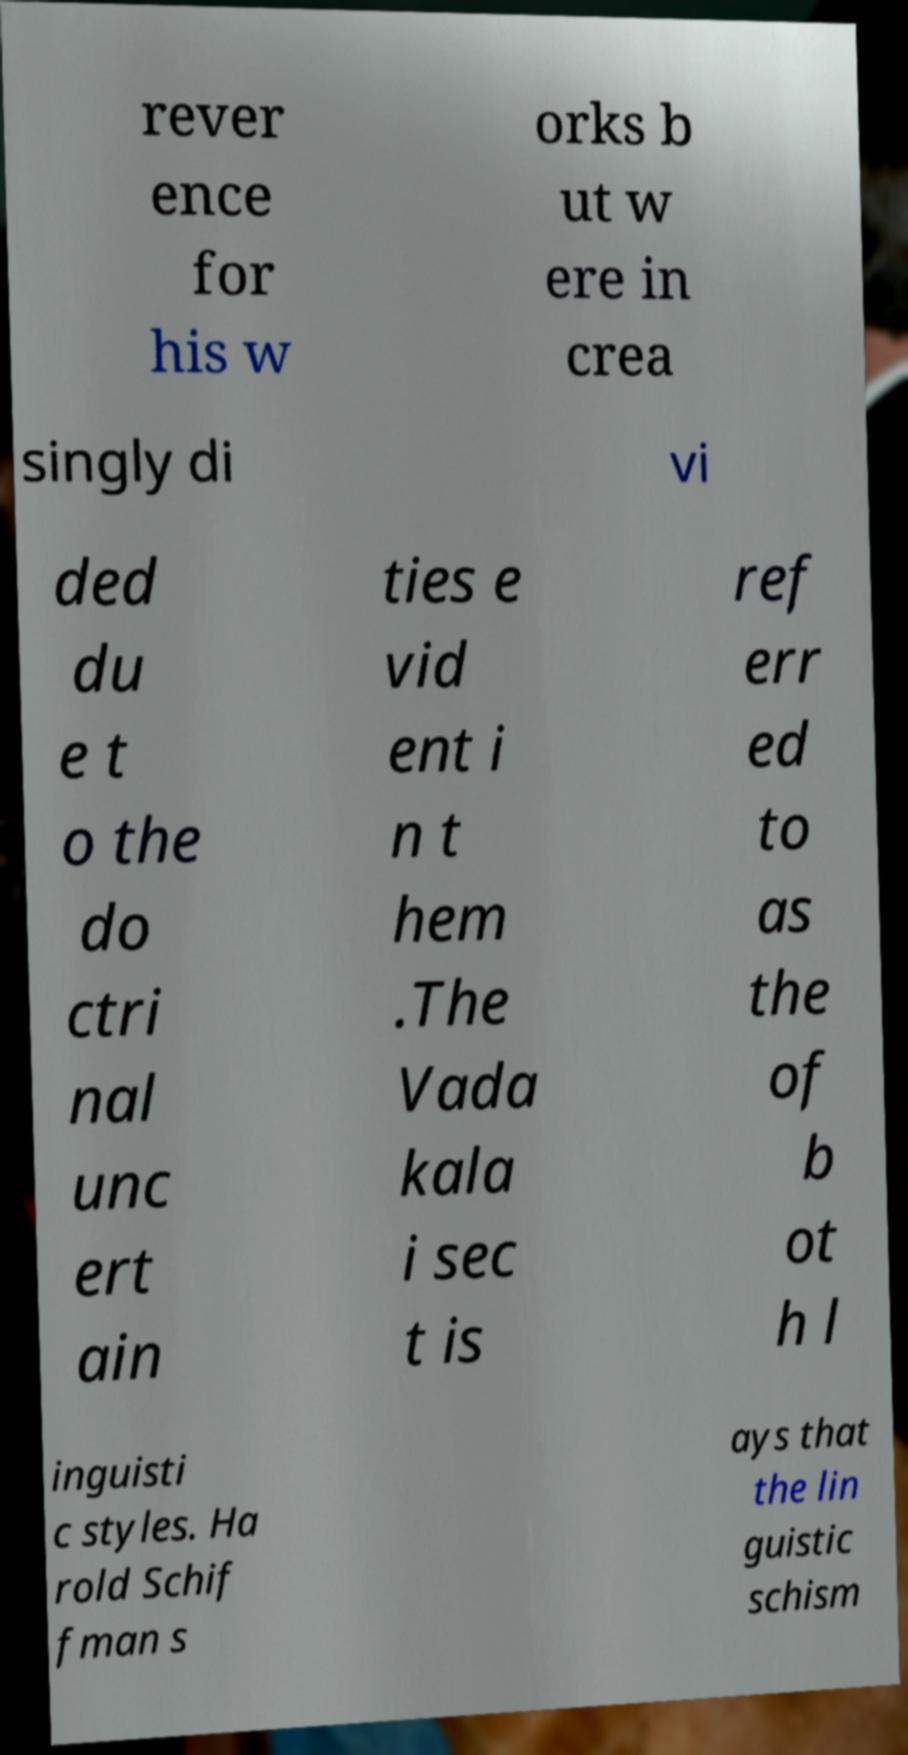Please read and relay the text visible in this image. What does it say? rever ence for his w orks b ut w ere in crea singly di vi ded du e t o the do ctri nal unc ert ain ties e vid ent i n t hem .The Vada kala i sec t is ref err ed to as the of b ot h l inguisti c styles. Ha rold Schif fman s ays that the lin guistic schism 